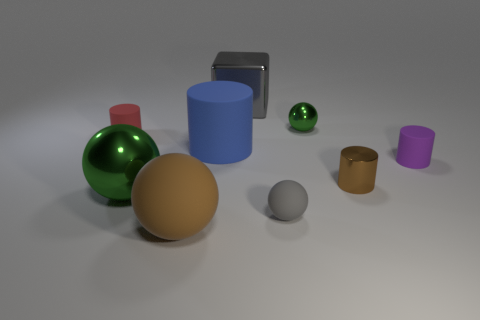Add 1 metallic cubes. How many objects exist? 10 Subtract all tiny green balls. How many balls are left? 3 Subtract all purple blocks. How many green spheres are left? 2 Subtract all blocks. How many objects are left? 8 Subtract 2 balls. How many balls are left? 2 Subtract all green spheres. How many spheres are left? 2 Subtract all blue cylinders. Subtract all blue blocks. How many cylinders are left? 3 Subtract all metallic cylinders. Subtract all big green metallic cubes. How many objects are left? 8 Add 3 small red rubber objects. How many small red rubber objects are left? 4 Add 6 tiny red matte objects. How many tiny red matte objects exist? 7 